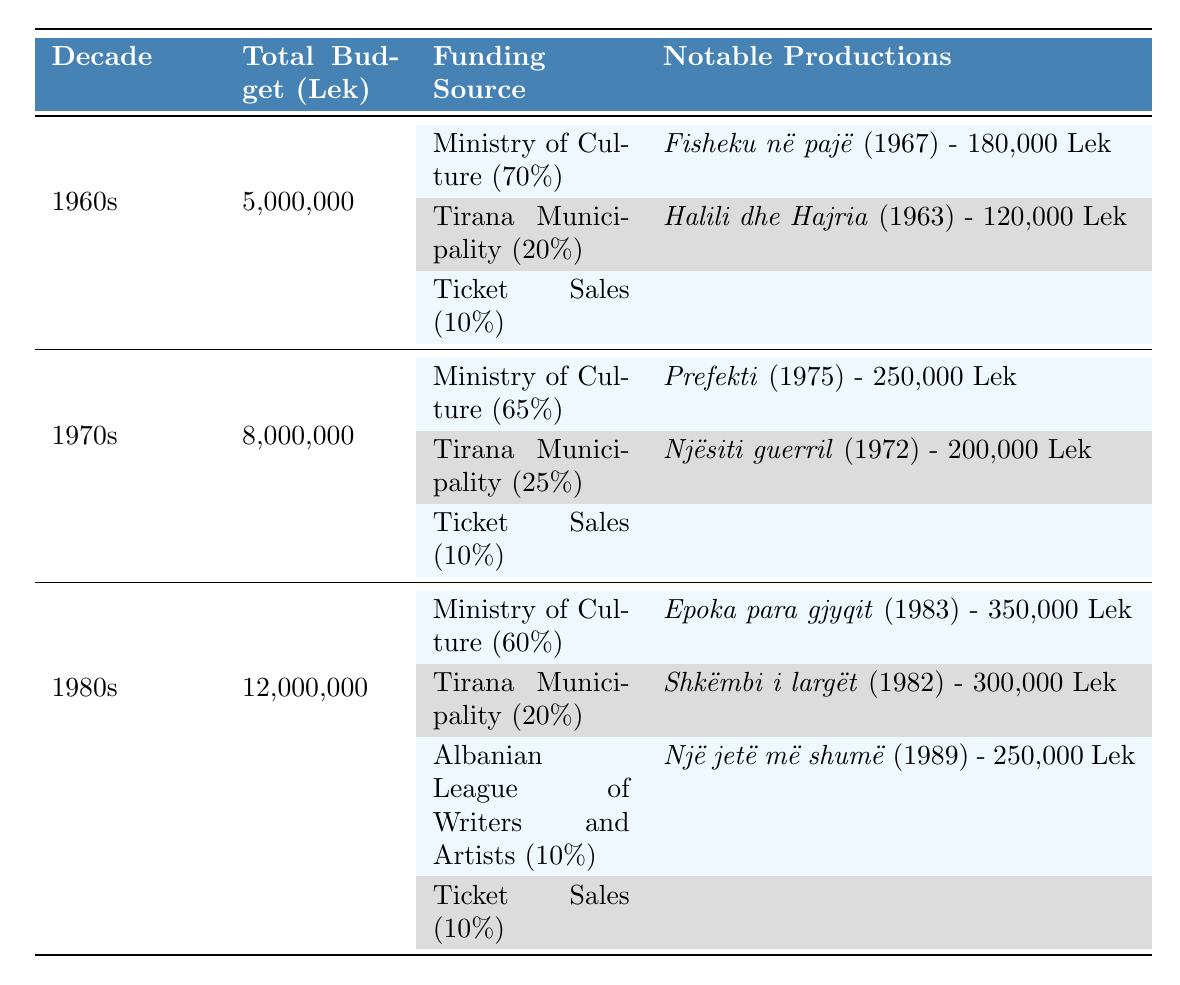What was the total budget for the Albanian National Theater in the 1960s? According to the table, the total budget allocated for the Albanian National Theater in the 1960s is listed as 5,000,000 Lek.
Answer: 5,000,000 Lek Which funding source contributed the most to the budget in the 1980s? The table shows that the Ministry of Culture contributed 60% of the total budget in the 1980s, which is the highest percentage compared to other sources.
Answer: Ministry of Culture What percentage of the budget in the 1970s came from ticket sales? The table indicates that ticket sales accounted for 10% of the total budget in the 1970s, which is stated clearly in the corresponding section.
Answer: 10% In which year was "Cuca e maleve" produced, and what was its budget? The table lists "Cuca e maleve" as produced in 1964 with a budget of 150,000 Lek. This information can be directly found under the notable productions for that decade.
Answer: 1964, 150,000 Lek What was the total budget allocated for the productions in the 1980s compared to the 1960s? To find this, we look at the total budgets: the 1980s total is 12,000,000 Lek and the 1960s total is 5,000,000 Lek. The difference is 12,000,000 - 5,000,000 = 7,000,000 Lek, indicating the budget in the 1980s was significantly higher.
Answer: 7,000,000 Lek Was any production in the 1970s funded by the Albanian League of Writers and Artists? The table does not list any notable productions funded by the Albanian League of Writers and Artists in the 1970s; all productions listed there are from the Ministry of Culture and Tirana Municipality.
Answer: No What is the average budget of productions in the 1980s that were funded by the Ministry of Culture? The notable productions funded by the Ministry of Culture in the 1980s include "Epoka para gjyqit" with 350,000 Lek and "Nëntori i dytë" with 380,000 Lek. Adding these budgets gives 350,000 + 380,000 = 730,000 Lek. There are 2 productions, so 730,000/2 = 365,000 Lek is the average budget.
Answer: 365,000 Lek How many productions were noted under the funding source "Tirana Municipality" in the 1960s? The table highlights that under "Tirana Municipality" in the 1960s, there is only one production noted, which is "Halili dhe Hajria."
Answer: 1 production If the total budget in the 1970s is 8,000,000 Lek, how much money came from Tirana Municipality? From the table, Tirana Municipality contributed 25% to the total budget in the 1970s. Calculating this means taking 25% of 8,000,000 Lek: 0.25 * 8,000,000 = 2,000,000 Lek.
Answer: 2,000,000 Lek Which decade recorded the highest total budget for productions? Looking at the total budgets across the decades, the 1980s recorded the highest total budget at 12,000,000 Lek, more than the 1960s (5,000,000 Lek) and 1970s (8,000,000 Lek).
Answer: 1980s 